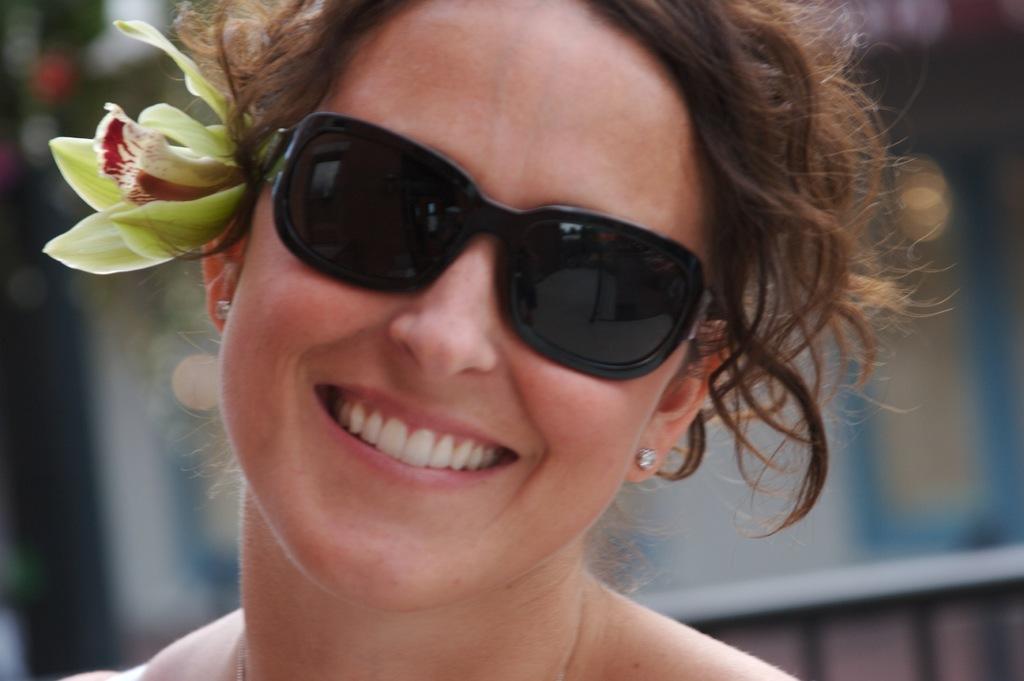How would you summarize this image in a sentence or two? Here we can see a woman laughing and she wore goggles to her eyes and there is a flower on her ear. 